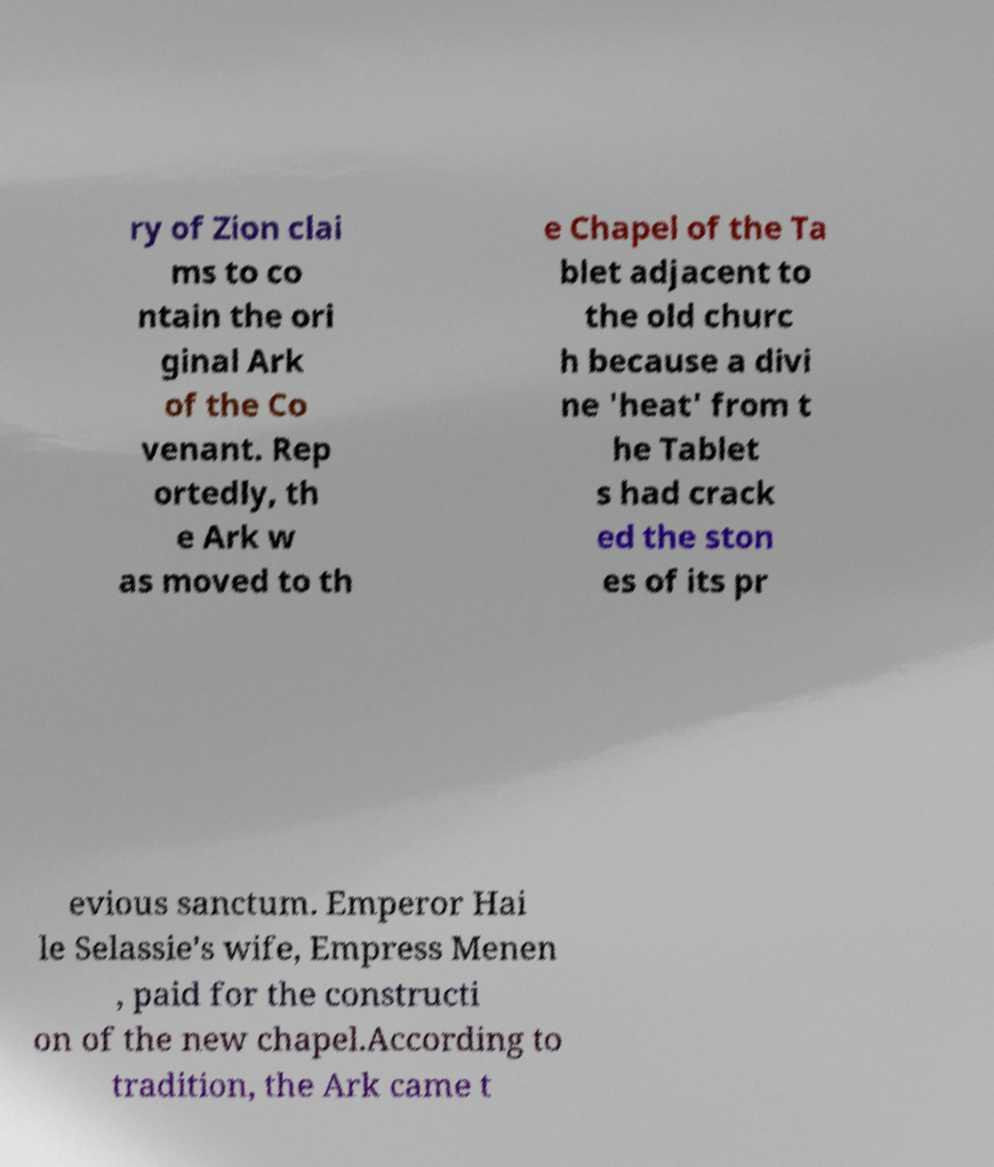I need the written content from this picture converted into text. Can you do that? ry of Zion clai ms to co ntain the ori ginal Ark of the Co venant. Rep ortedly, th e Ark w as moved to th e Chapel of the Ta blet adjacent to the old churc h because a divi ne 'heat' from t he Tablet s had crack ed the ston es of its pr evious sanctum. Emperor Hai le Selassie's wife, Empress Menen , paid for the constructi on of the new chapel.According to tradition, the Ark came t 